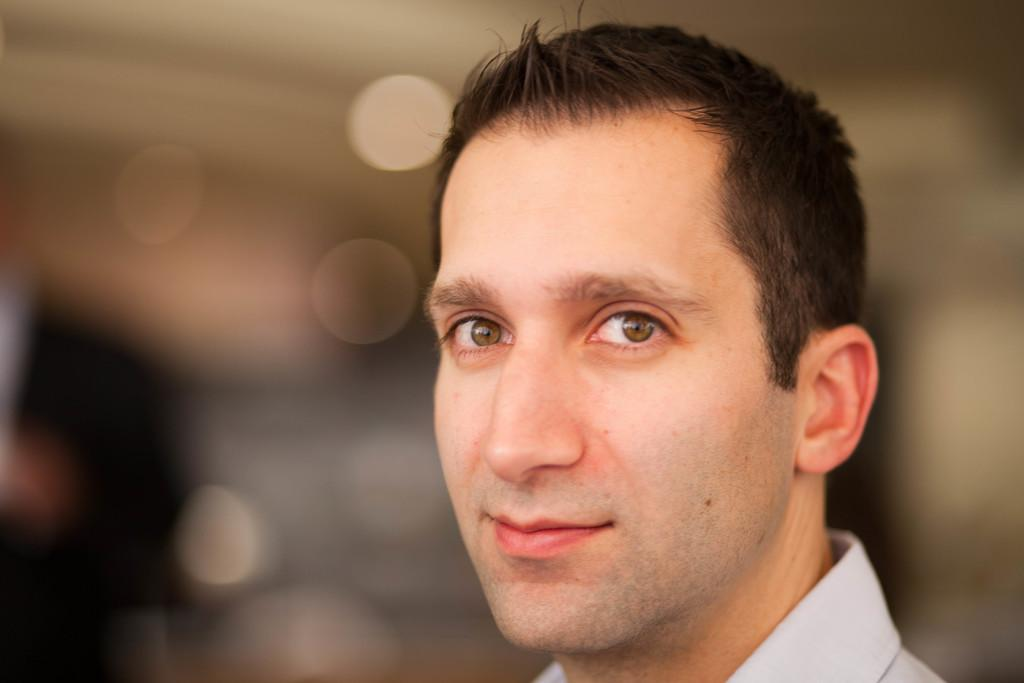What is present in the image? There is a man in the image. Can you describe the man's clothing? The man is wearing a white shirt. What can be observed about the background of the image? The background of the image is blurry. What type of oven can be seen in the image? There is no oven present in the image. How many ants are visible on the man's shirt in the image? There are no ants visible on the man's shirt in the image. 